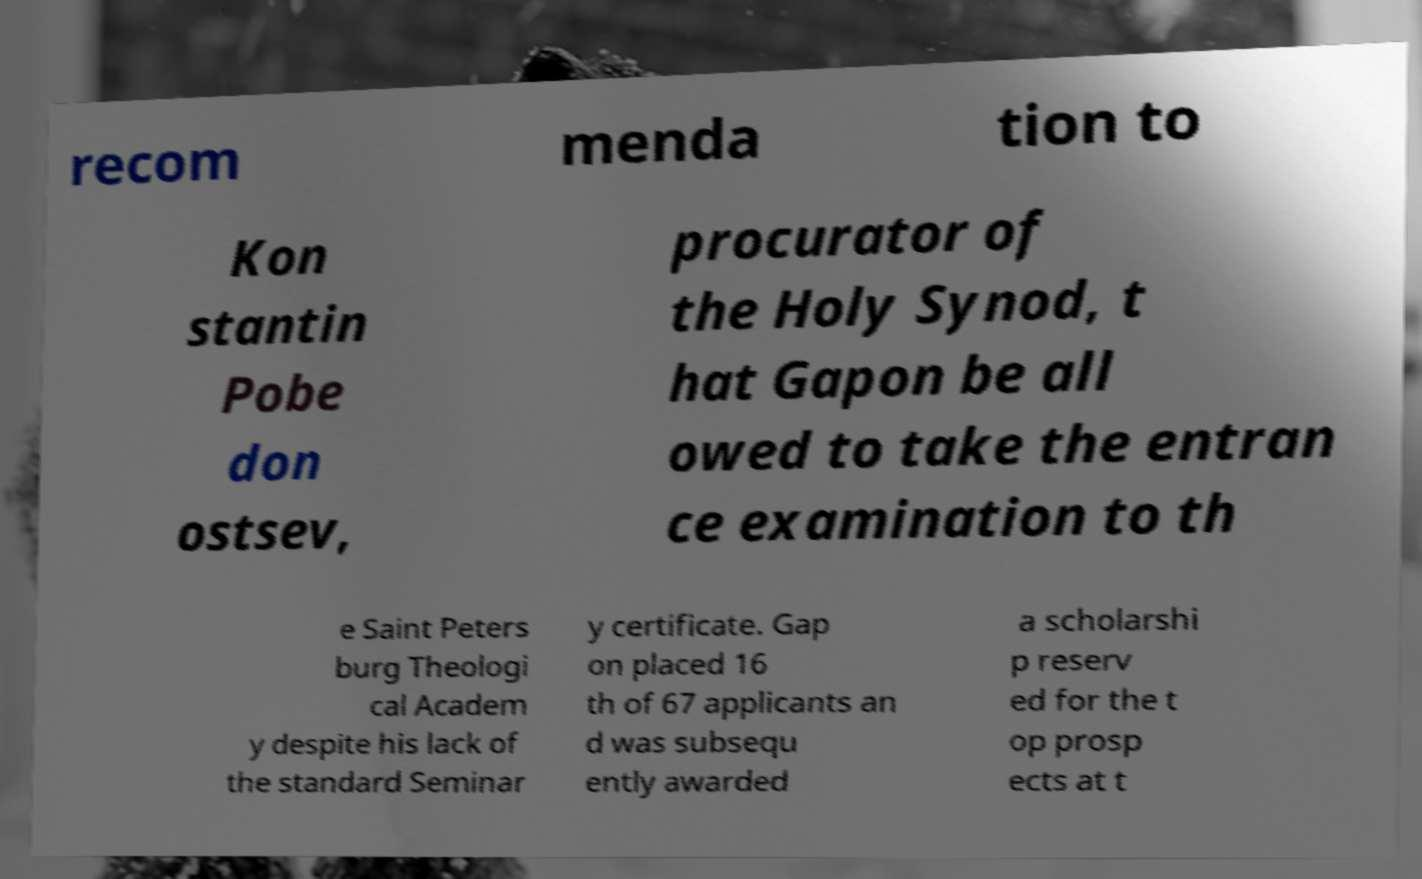Please identify and transcribe the text found in this image. recom menda tion to Kon stantin Pobe don ostsev, procurator of the Holy Synod, t hat Gapon be all owed to take the entran ce examination to th e Saint Peters burg Theologi cal Academ y despite his lack of the standard Seminar y certificate. Gap on placed 16 th of 67 applicants an d was subsequ ently awarded a scholarshi p reserv ed for the t op prosp ects at t 